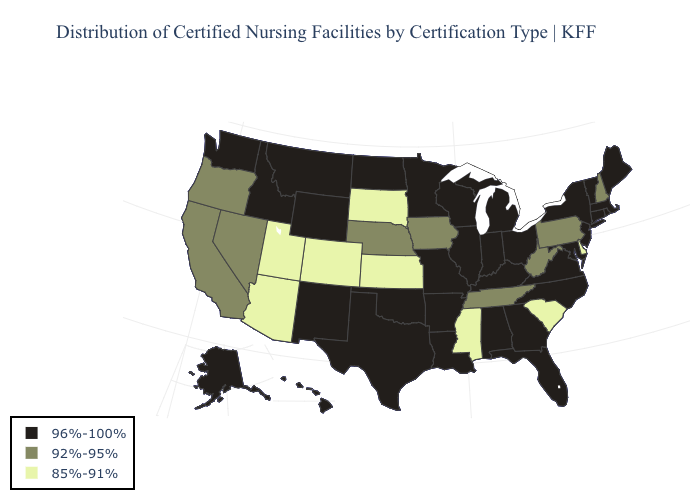Does Kansas have the lowest value in the USA?
Concise answer only. Yes. Does New Mexico have a higher value than Wisconsin?
Write a very short answer. No. Which states have the highest value in the USA?
Be succinct. Alabama, Alaska, Arkansas, Connecticut, Florida, Georgia, Hawaii, Idaho, Illinois, Indiana, Kentucky, Louisiana, Maine, Maryland, Massachusetts, Michigan, Minnesota, Missouri, Montana, New Jersey, New Mexico, New York, North Carolina, North Dakota, Ohio, Oklahoma, Rhode Island, Texas, Vermont, Virginia, Washington, Wisconsin, Wyoming. Does North Dakota have the same value as Mississippi?
Keep it brief. No. Name the states that have a value in the range 92%-95%?
Quick response, please. California, Iowa, Nebraska, Nevada, New Hampshire, Oregon, Pennsylvania, Tennessee, West Virginia. Among the states that border Texas , which have the lowest value?
Give a very brief answer. Arkansas, Louisiana, New Mexico, Oklahoma. What is the value of Minnesota?
Quick response, please. 96%-100%. Name the states that have a value in the range 96%-100%?
Keep it brief. Alabama, Alaska, Arkansas, Connecticut, Florida, Georgia, Hawaii, Idaho, Illinois, Indiana, Kentucky, Louisiana, Maine, Maryland, Massachusetts, Michigan, Minnesota, Missouri, Montana, New Jersey, New Mexico, New York, North Carolina, North Dakota, Ohio, Oklahoma, Rhode Island, Texas, Vermont, Virginia, Washington, Wisconsin, Wyoming. Does the first symbol in the legend represent the smallest category?
Write a very short answer. No. What is the lowest value in states that border New York?
Short answer required. 92%-95%. Does Indiana have the highest value in the USA?
Concise answer only. Yes. What is the highest value in the Northeast ?
Keep it brief. 96%-100%. Which states hav the highest value in the MidWest?
Keep it brief. Illinois, Indiana, Michigan, Minnesota, Missouri, North Dakota, Ohio, Wisconsin. Does California have a lower value than Alabama?
Give a very brief answer. Yes. 